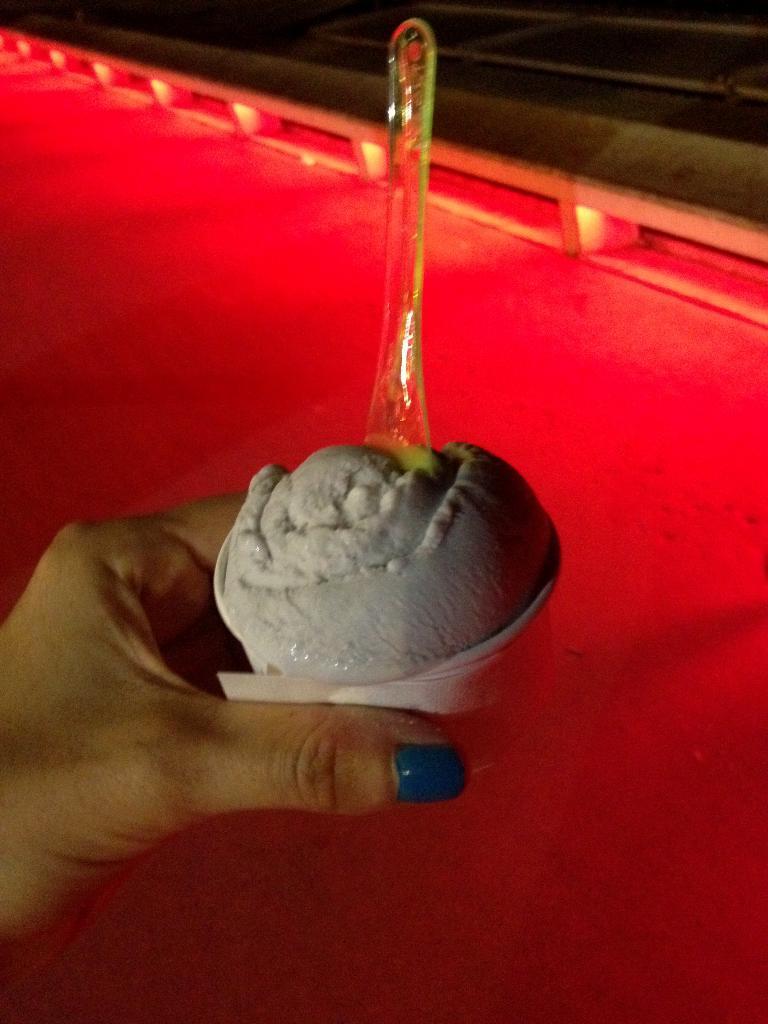In one or two sentences, can you explain what this image depicts? In the picture we can see a person hand holding a cup with ice cream and a spoon on it and under it we can see a red color carpet and railing beside it. 